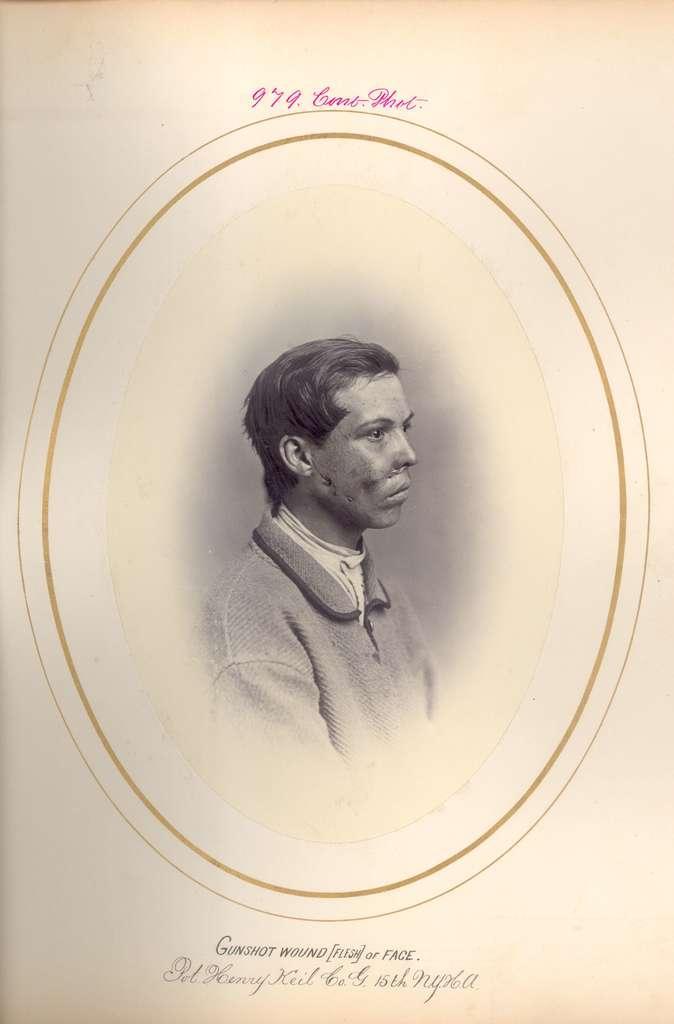How would you summarize this image in a sentence or two? In the image we can see a frame. 